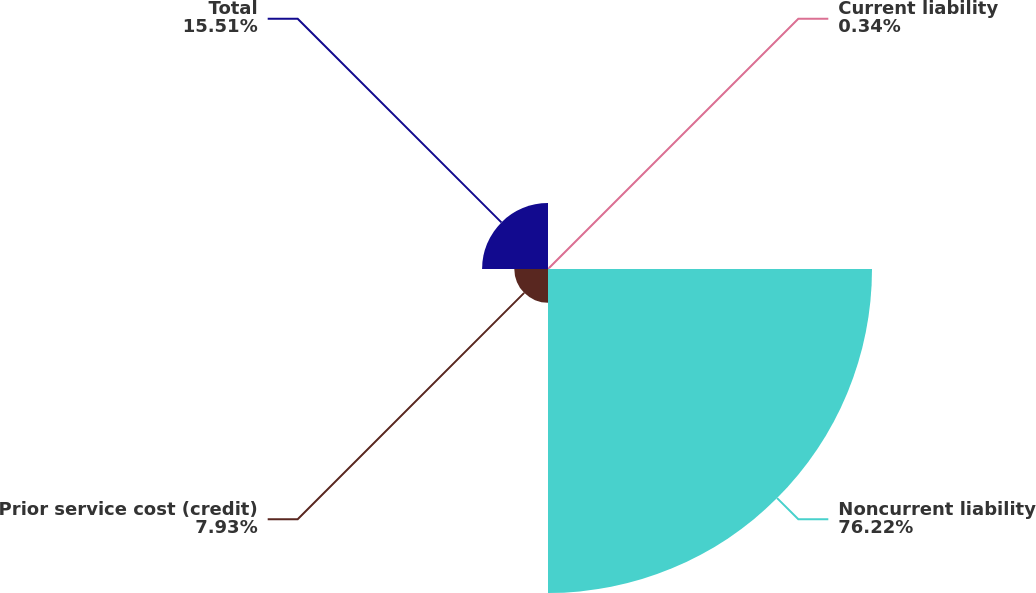<chart> <loc_0><loc_0><loc_500><loc_500><pie_chart><fcel>Current liability<fcel>Noncurrent liability<fcel>Prior service cost (credit)<fcel>Total<nl><fcel>0.34%<fcel>76.22%<fcel>7.93%<fcel>15.51%<nl></chart> 